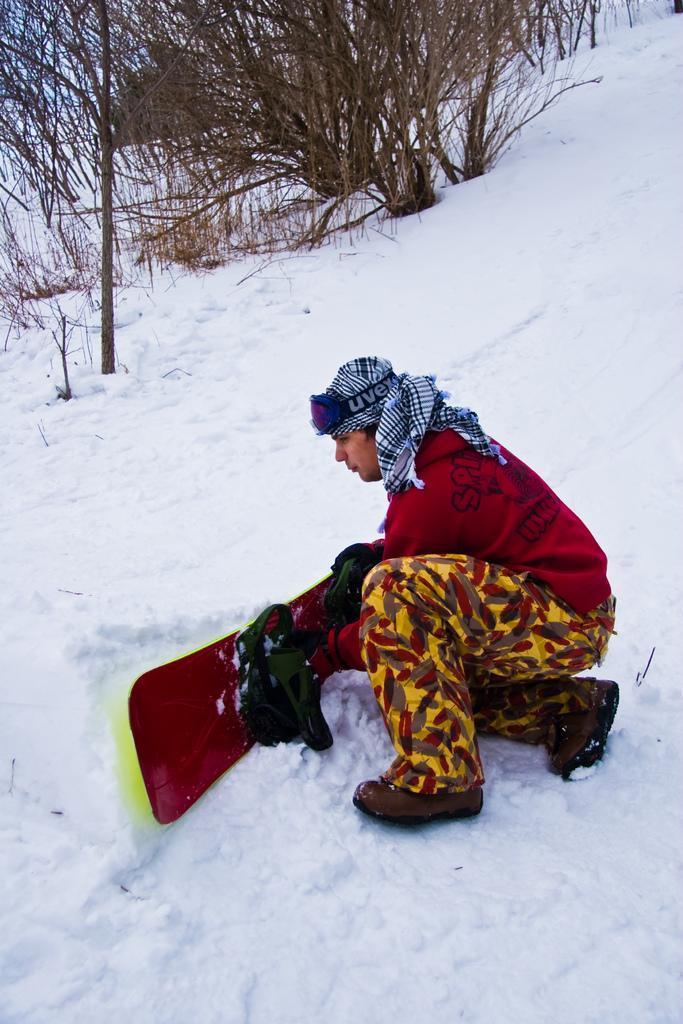Please provide a concise description of this image. In this picture I can see a person with a snowboard on the snow, and in the background there are trees. 